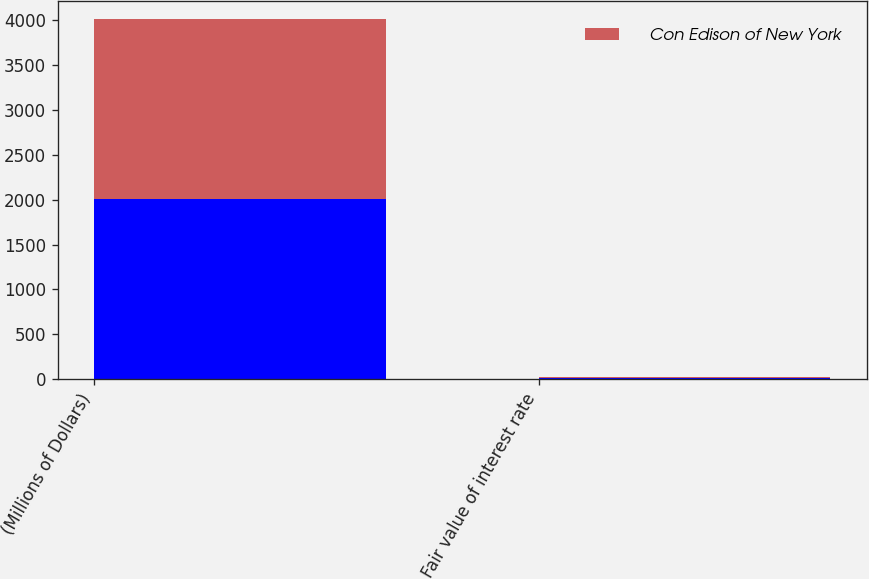<chart> <loc_0><loc_0><loc_500><loc_500><stacked_bar_chart><ecel><fcel>(Millions of Dollars)<fcel>Fair value of interest rate<nl><fcel>nan<fcel>2005<fcel>18<nl><fcel>Con Edison of New York<fcel>2005<fcel>3<nl></chart> 